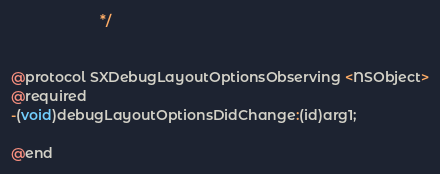Convert code to text. <code><loc_0><loc_0><loc_500><loc_500><_C_>                       */


@protocol SXDebugLayoutOptionsObserving <NSObject>
@required
-(void)debugLayoutOptionsDidChange:(id)arg1;

@end

</code> 